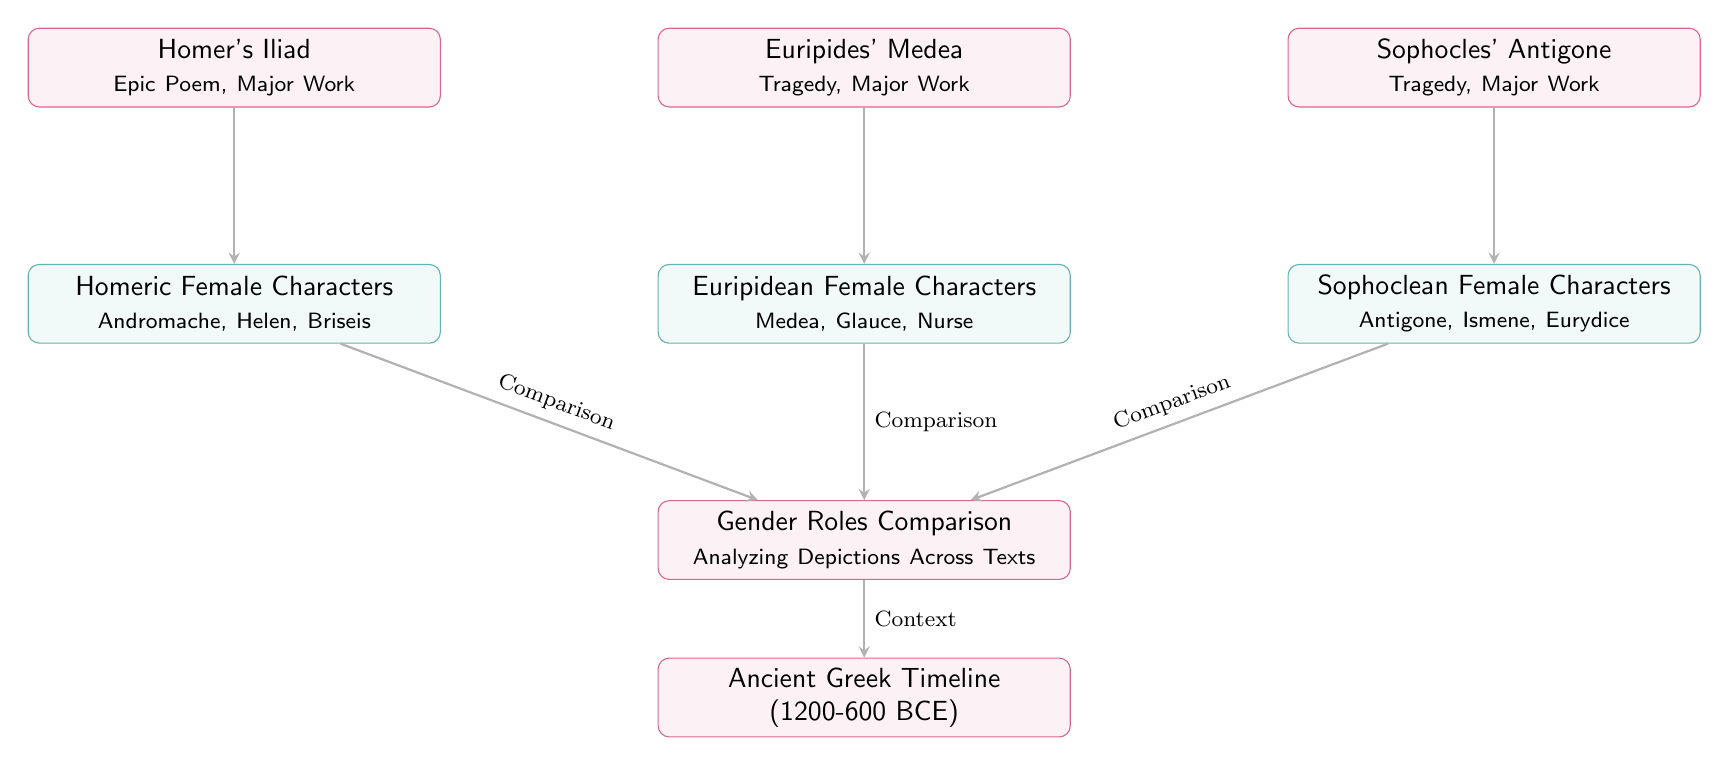What is the title of the timeline depicted in the diagram? The timeline node explicitly states "Ancient Greek Timeline (1200-600 BCE)," so we directly take this text as the title of the timeline.
Answer: Ancient Greek Timeline (1200-600 BCE) How many major works are highlighted in the diagram? There are three major works mentioned: Homer's Iliad, Euripides' Medea, and Sophocles' Antigone. By counting these nodes, we find there are three major works in total.
Answer: 3 Which female characters are associated with Euripides' work? The node for Euripides' Medea lists the female characters as Medea, Glauce, and Nurse. This is directly stated in the corresponding text.
Answer: Medea, Glauce, Nurse What is the relationship between "Homeric Female Characters" and "Gender Roles Comparison"? The diagram shows an arrow indicating a "Comparison" from the "Homeric Female Characters" node to the "Gender Roles Comparison" node, illustrating a direct comparative relationship.
Answer: Comparison How many distinct types of female characters are identified in the diagram? The diagram includes three types of female characters: Homeric, Euripidean, and Sophoclean. This can be identified by counting the distinct character type nodes shown.
Answer: 3 What does the arrow from "Gender Roles Comparison" to "Ancient Greek Timeline" signify? The arrow is labeled "Context," indicating that the Comparisons made among the female characters provide contextual information about the era specified in the timeline.
Answer: Context Which major works are shown in the diagram? The major works listed include Homer's Iliad, Euripides' Medea, and Sophocles' Antigone directly from the labels of the respective nodes.
Answer: Iliad, Medea, Antigone What type of diagram is being represented here? This diagram represents a systematic comparison of gender roles as depicted through ancient Greek literature, therefore it is best classified as a Textbook Diagram.
Answer: Textbook Diagram 